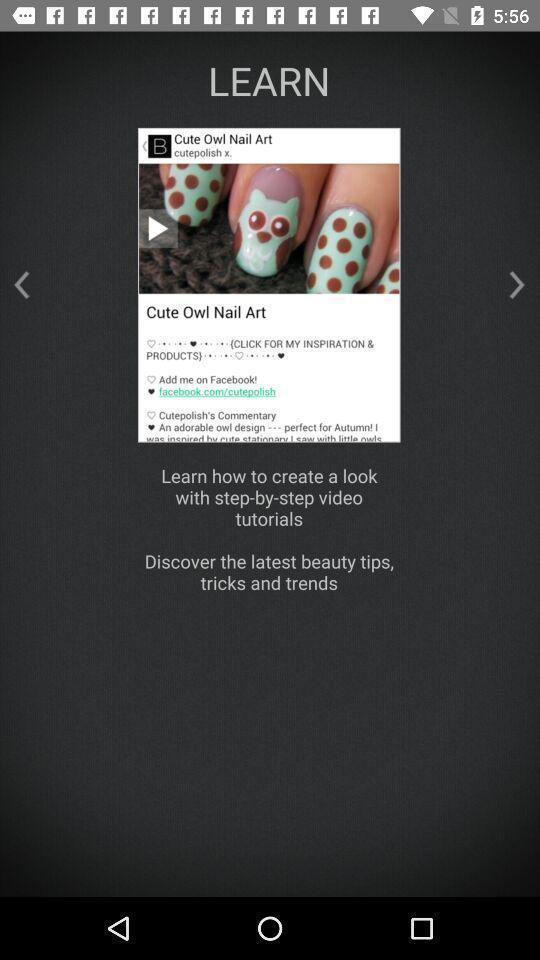What can you discern from this picture? Pop up displaying the cute owl nail art. 